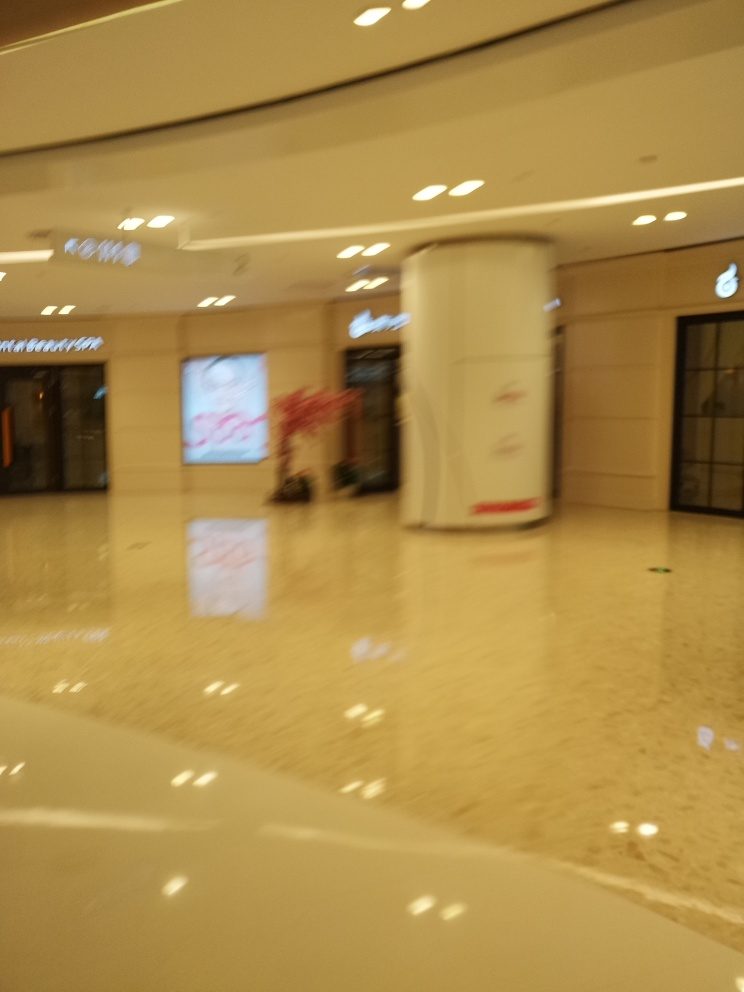What type of location does this image depict, despite the poor quality? Despite the low quality, the image seems to depict an indoor setting with artificial lighting that could be a mall or a commercial space, as suggested by the presence of storefronts and signage. 